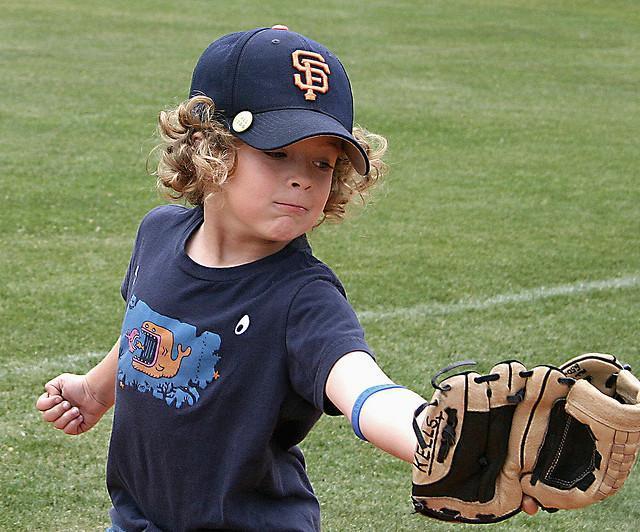How many trains are there?
Give a very brief answer. 0. 